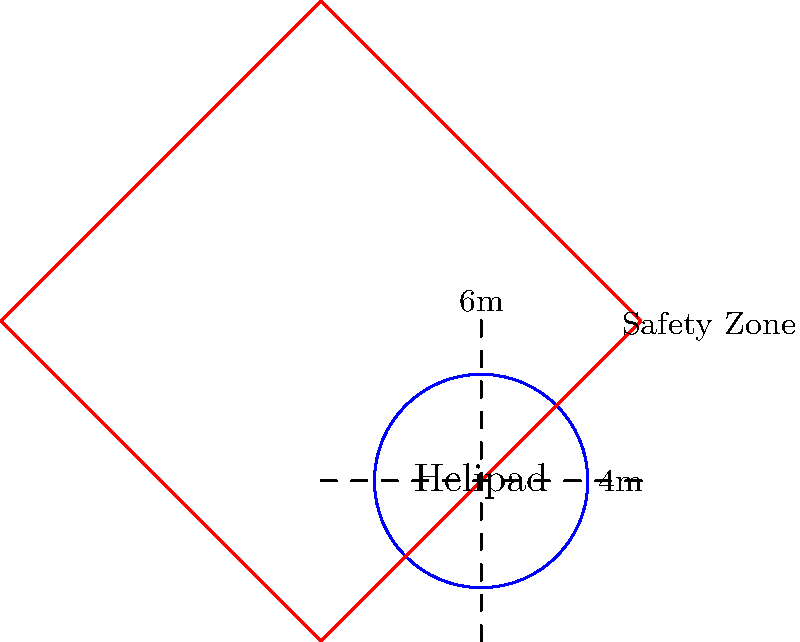A combat engineer unit is tasked with constructing a circular helipad surrounded by a square safety zone. The diameter of the helipad is 4 meters, and the safety zone extends 1 meter beyond the helipad on all sides, creating a 6-meter by 6-meter square. Calculate the total area that needs to be cleared and prepared, including both the helipad and the safety zone. To solve this problem, we need to follow these steps:

1) Calculate the area of the circular helipad:
   - Radius of helipad = $2$ meters
   - Area of circle = $\pi r^2$
   - Area of helipad = $\pi (2)^2 = 4\pi$ square meters

2) Calculate the area of the square safety zone:
   - Side length of square = $6$ meters
   - Area of square = $side^2$
   - Area of safety zone = $6^2 = 36$ square meters

3) Calculate the total area:
   Total area = Area of safety zone
   Total area = $36$ square meters

Note: We don't need to add the area of the helipad separately because it's already included in the area of the square safety zone.
Answer: $36$ square meters 